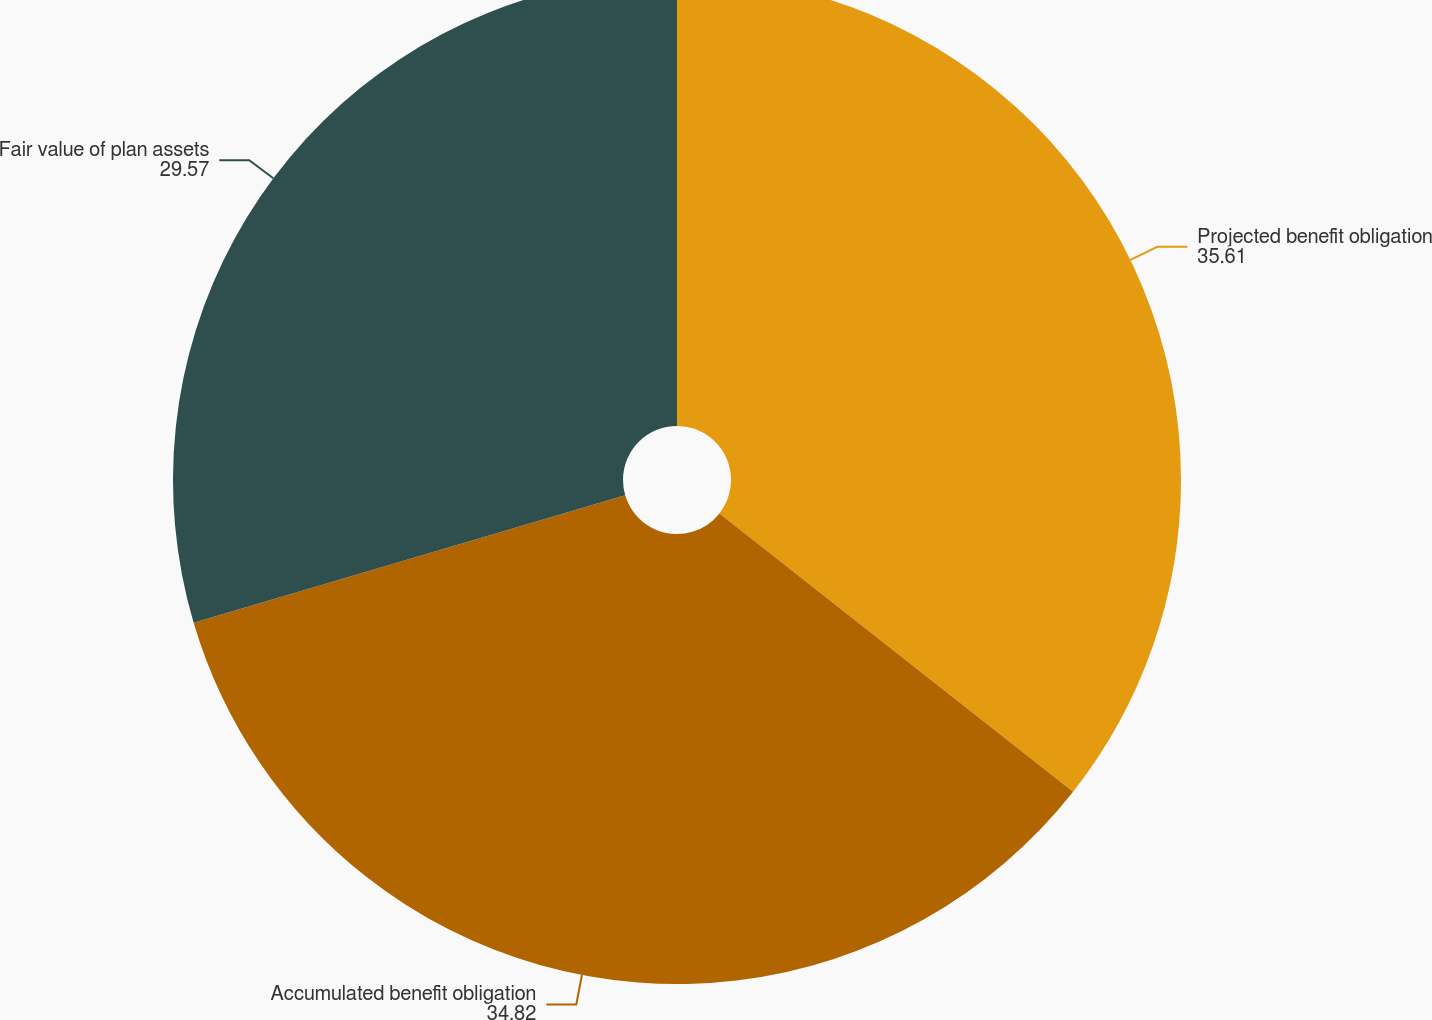Convert chart to OTSL. <chart><loc_0><loc_0><loc_500><loc_500><pie_chart><fcel>Projected benefit obligation<fcel>Accumulated benefit obligation<fcel>Fair value of plan assets<nl><fcel>35.61%<fcel>34.82%<fcel>29.57%<nl></chart> 